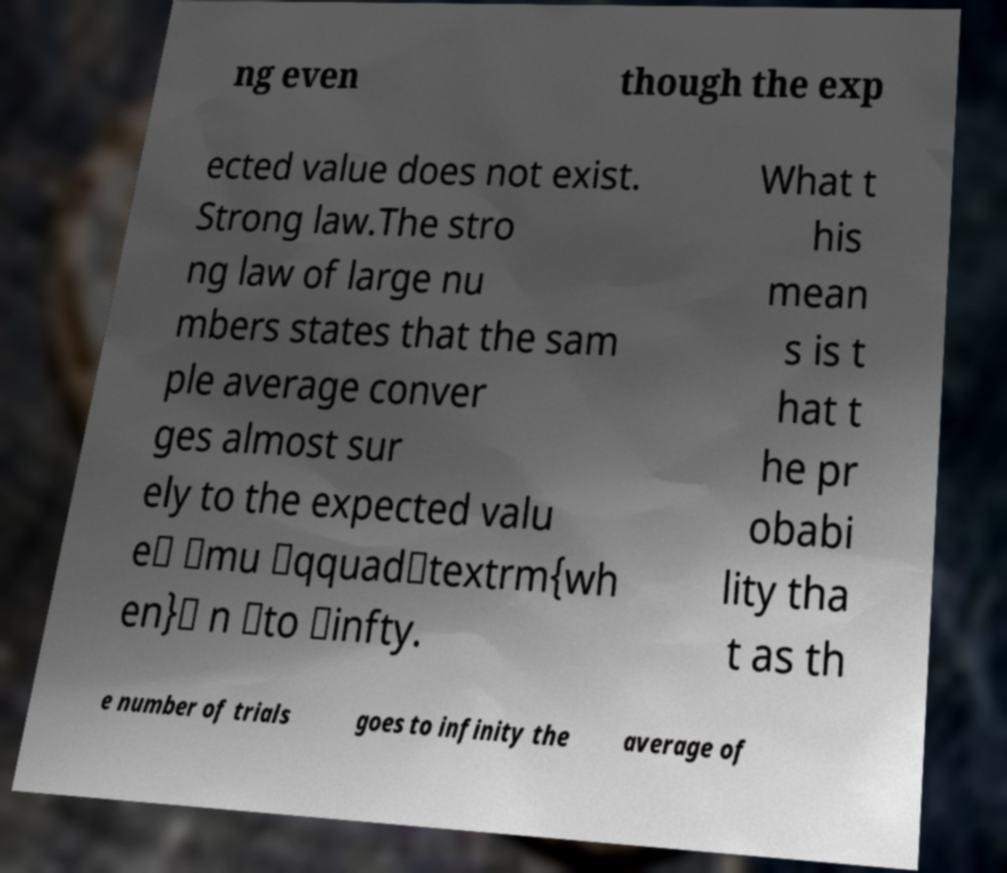Please read and relay the text visible in this image. What does it say? ng even though the exp ected value does not exist. Strong law.The stro ng law of large nu mbers states that the sam ple average conver ges almost sur ely to the expected valu e\ \mu \qquad\textrm{wh en}\ n \to \infty. What t his mean s is t hat t he pr obabi lity tha t as th e number of trials goes to infinity the average of 